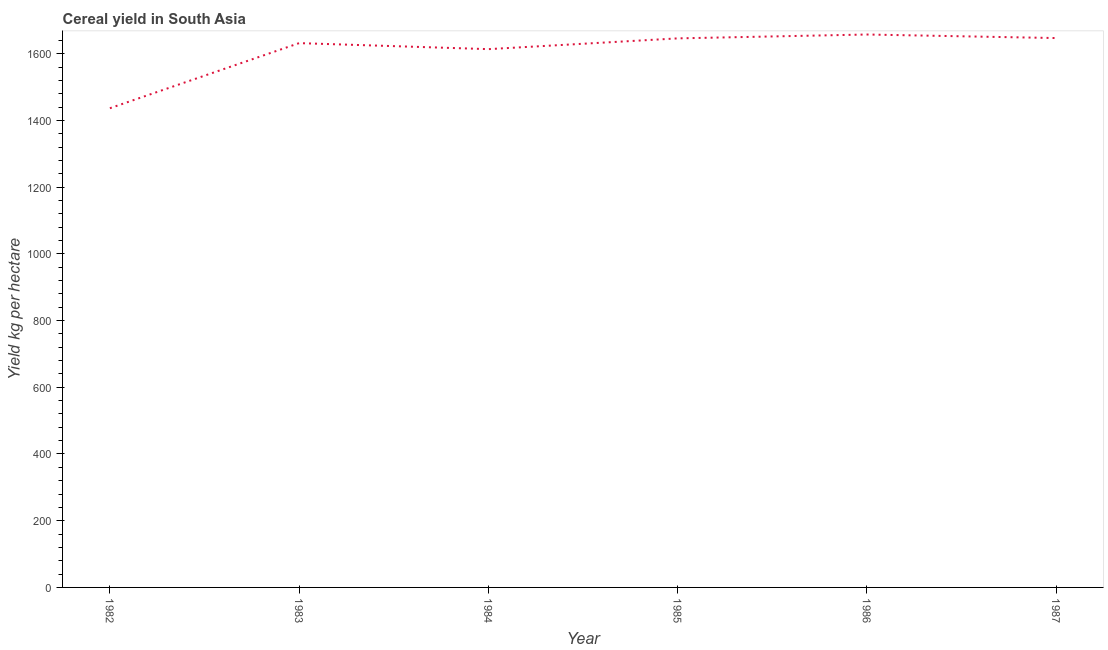What is the cereal yield in 1983?
Give a very brief answer. 1631.76. Across all years, what is the maximum cereal yield?
Your answer should be very brief. 1657.58. Across all years, what is the minimum cereal yield?
Make the answer very short. 1436.6. In which year was the cereal yield maximum?
Provide a succinct answer. 1986. In which year was the cereal yield minimum?
Make the answer very short. 1982. What is the sum of the cereal yield?
Offer a very short reply. 9632.61. What is the difference between the cereal yield in 1986 and 1987?
Ensure brevity in your answer.  10.65. What is the average cereal yield per year?
Give a very brief answer. 1605.43. What is the median cereal yield?
Your answer should be compact. 1638.88. In how many years, is the cereal yield greater than 40 kg per hectare?
Your answer should be very brief. 6. What is the ratio of the cereal yield in 1985 to that in 1986?
Provide a succinct answer. 0.99. What is the difference between the highest and the second highest cereal yield?
Your answer should be compact. 10.65. Is the sum of the cereal yield in 1983 and 1985 greater than the maximum cereal yield across all years?
Make the answer very short. Yes. What is the difference between the highest and the lowest cereal yield?
Offer a very short reply. 220.98. Does the cereal yield monotonically increase over the years?
Provide a short and direct response. No. How many lines are there?
Your answer should be compact. 1. What is the difference between two consecutive major ticks on the Y-axis?
Your answer should be compact. 200. What is the title of the graph?
Your response must be concise. Cereal yield in South Asia. What is the label or title of the X-axis?
Provide a succinct answer. Year. What is the label or title of the Y-axis?
Make the answer very short. Yield kg per hectare. What is the Yield kg per hectare in 1982?
Make the answer very short. 1436.6. What is the Yield kg per hectare in 1983?
Provide a succinct answer. 1631.76. What is the Yield kg per hectare of 1984?
Offer a terse response. 1613.72. What is the Yield kg per hectare of 1985?
Provide a short and direct response. 1646.01. What is the Yield kg per hectare in 1986?
Your answer should be very brief. 1657.58. What is the Yield kg per hectare of 1987?
Your answer should be compact. 1646.93. What is the difference between the Yield kg per hectare in 1982 and 1983?
Make the answer very short. -195.15. What is the difference between the Yield kg per hectare in 1982 and 1984?
Offer a very short reply. -177.12. What is the difference between the Yield kg per hectare in 1982 and 1985?
Offer a very short reply. -209.4. What is the difference between the Yield kg per hectare in 1982 and 1986?
Offer a very short reply. -220.98. What is the difference between the Yield kg per hectare in 1982 and 1987?
Offer a very short reply. -210.33. What is the difference between the Yield kg per hectare in 1983 and 1984?
Keep it short and to the point. 18.04. What is the difference between the Yield kg per hectare in 1983 and 1985?
Provide a succinct answer. -14.25. What is the difference between the Yield kg per hectare in 1983 and 1986?
Make the answer very short. -25.83. What is the difference between the Yield kg per hectare in 1983 and 1987?
Offer a terse response. -15.18. What is the difference between the Yield kg per hectare in 1984 and 1985?
Offer a very short reply. -32.29. What is the difference between the Yield kg per hectare in 1984 and 1986?
Your answer should be very brief. -43.86. What is the difference between the Yield kg per hectare in 1984 and 1987?
Offer a terse response. -33.21. What is the difference between the Yield kg per hectare in 1985 and 1986?
Keep it short and to the point. -11.58. What is the difference between the Yield kg per hectare in 1985 and 1987?
Give a very brief answer. -0.93. What is the difference between the Yield kg per hectare in 1986 and 1987?
Offer a very short reply. 10.65. What is the ratio of the Yield kg per hectare in 1982 to that in 1983?
Offer a very short reply. 0.88. What is the ratio of the Yield kg per hectare in 1982 to that in 1984?
Your answer should be compact. 0.89. What is the ratio of the Yield kg per hectare in 1982 to that in 1985?
Your answer should be very brief. 0.87. What is the ratio of the Yield kg per hectare in 1982 to that in 1986?
Ensure brevity in your answer.  0.87. What is the ratio of the Yield kg per hectare in 1982 to that in 1987?
Your answer should be compact. 0.87. What is the ratio of the Yield kg per hectare in 1984 to that in 1986?
Keep it short and to the point. 0.97. What is the ratio of the Yield kg per hectare in 1985 to that in 1987?
Provide a short and direct response. 1. What is the ratio of the Yield kg per hectare in 1986 to that in 1987?
Make the answer very short. 1.01. 